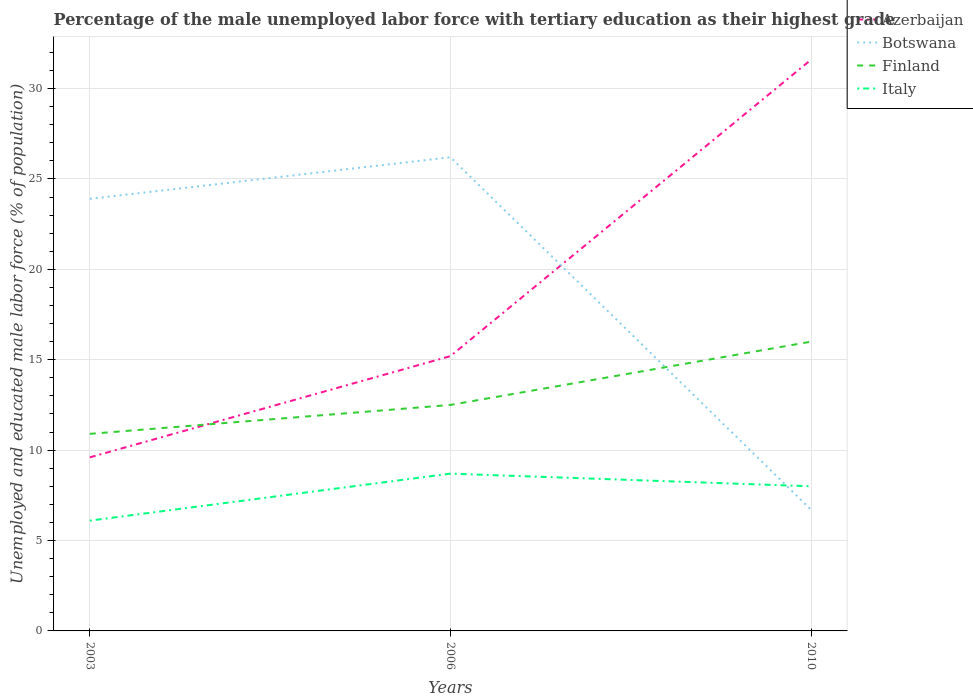How many different coloured lines are there?
Ensure brevity in your answer.  4. Does the line corresponding to Finland intersect with the line corresponding to Botswana?
Keep it short and to the point. Yes. Is the number of lines equal to the number of legend labels?
Make the answer very short. Yes. Across all years, what is the maximum percentage of the unemployed male labor force with tertiary education in Finland?
Make the answer very short. 10.9. In which year was the percentage of the unemployed male labor force with tertiary education in Finland maximum?
Ensure brevity in your answer.  2003. What is the total percentage of the unemployed male labor force with tertiary education in Finland in the graph?
Offer a terse response. -5.1. What is the difference between the highest and the second highest percentage of the unemployed male labor force with tertiary education in Azerbaijan?
Provide a succinct answer. 22. Is the percentage of the unemployed male labor force with tertiary education in Botswana strictly greater than the percentage of the unemployed male labor force with tertiary education in Finland over the years?
Your answer should be compact. No. How many lines are there?
Your answer should be very brief. 4. What is the difference between two consecutive major ticks on the Y-axis?
Make the answer very short. 5. Does the graph contain grids?
Your answer should be compact. Yes. Where does the legend appear in the graph?
Provide a succinct answer. Top right. What is the title of the graph?
Make the answer very short. Percentage of the male unemployed labor force with tertiary education as their highest grade. What is the label or title of the X-axis?
Your response must be concise. Years. What is the label or title of the Y-axis?
Your answer should be compact. Unemployed and educated male labor force (% of population). What is the Unemployed and educated male labor force (% of population) of Azerbaijan in 2003?
Your response must be concise. 9.6. What is the Unemployed and educated male labor force (% of population) of Botswana in 2003?
Your answer should be very brief. 23.9. What is the Unemployed and educated male labor force (% of population) in Finland in 2003?
Keep it short and to the point. 10.9. What is the Unemployed and educated male labor force (% of population) of Italy in 2003?
Ensure brevity in your answer.  6.1. What is the Unemployed and educated male labor force (% of population) of Azerbaijan in 2006?
Offer a terse response. 15.2. What is the Unemployed and educated male labor force (% of population) of Botswana in 2006?
Keep it short and to the point. 26.2. What is the Unemployed and educated male labor force (% of population) of Italy in 2006?
Your answer should be compact. 8.7. What is the Unemployed and educated male labor force (% of population) in Azerbaijan in 2010?
Give a very brief answer. 31.6. What is the Unemployed and educated male labor force (% of population) of Botswana in 2010?
Keep it short and to the point. 6.7. What is the Unemployed and educated male labor force (% of population) of Finland in 2010?
Provide a succinct answer. 16. What is the Unemployed and educated male labor force (% of population) of Italy in 2010?
Keep it short and to the point. 8. Across all years, what is the maximum Unemployed and educated male labor force (% of population) in Azerbaijan?
Your answer should be very brief. 31.6. Across all years, what is the maximum Unemployed and educated male labor force (% of population) of Botswana?
Keep it short and to the point. 26.2. Across all years, what is the maximum Unemployed and educated male labor force (% of population) in Finland?
Offer a very short reply. 16. Across all years, what is the maximum Unemployed and educated male labor force (% of population) in Italy?
Ensure brevity in your answer.  8.7. Across all years, what is the minimum Unemployed and educated male labor force (% of population) of Azerbaijan?
Your answer should be very brief. 9.6. Across all years, what is the minimum Unemployed and educated male labor force (% of population) in Botswana?
Offer a very short reply. 6.7. Across all years, what is the minimum Unemployed and educated male labor force (% of population) of Finland?
Offer a very short reply. 10.9. Across all years, what is the minimum Unemployed and educated male labor force (% of population) of Italy?
Ensure brevity in your answer.  6.1. What is the total Unemployed and educated male labor force (% of population) in Azerbaijan in the graph?
Offer a very short reply. 56.4. What is the total Unemployed and educated male labor force (% of population) of Botswana in the graph?
Give a very brief answer. 56.8. What is the total Unemployed and educated male labor force (% of population) of Finland in the graph?
Offer a terse response. 39.4. What is the total Unemployed and educated male labor force (% of population) in Italy in the graph?
Ensure brevity in your answer.  22.8. What is the difference between the Unemployed and educated male labor force (% of population) of Botswana in 2003 and that in 2006?
Provide a short and direct response. -2.3. What is the difference between the Unemployed and educated male labor force (% of population) in Finland in 2003 and that in 2006?
Make the answer very short. -1.6. What is the difference between the Unemployed and educated male labor force (% of population) in Azerbaijan in 2003 and that in 2010?
Your response must be concise. -22. What is the difference between the Unemployed and educated male labor force (% of population) of Botswana in 2003 and that in 2010?
Offer a very short reply. 17.2. What is the difference between the Unemployed and educated male labor force (% of population) of Finland in 2003 and that in 2010?
Your answer should be compact. -5.1. What is the difference between the Unemployed and educated male labor force (% of population) in Azerbaijan in 2006 and that in 2010?
Offer a terse response. -16.4. What is the difference between the Unemployed and educated male labor force (% of population) in Botswana in 2006 and that in 2010?
Your answer should be very brief. 19.5. What is the difference between the Unemployed and educated male labor force (% of population) in Azerbaijan in 2003 and the Unemployed and educated male labor force (% of population) in Botswana in 2006?
Offer a terse response. -16.6. What is the difference between the Unemployed and educated male labor force (% of population) of Azerbaijan in 2003 and the Unemployed and educated male labor force (% of population) of Finland in 2006?
Offer a terse response. -2.9. What is the difference between the Unemployed and educated male labor force (% of population) of Azerbaijan in 2003 and the Unemployed and educated male labor force (% of population) of Italy in 2006?
Offer a terse response. 0.9. What is the difference between the Unemployed and educated male labor force (% of population) in Botswana in 2003 and the Unemployed and educated male labor force (% of population) in Finland in 2006?
Make the answer very short. 11.4. What is the difference between the Unemployed and educated male labor force (% of population) in Botswana in 2003 and the Unemployed and educated male labor force (% of population) in Italy in 2006?
Offer a very short reply. 15.2. What is the difference between the Unemployed and educated male labor force (% of population) in Finland in 2003 and the Unemployed and educated male labor force (% of population) in Italy in 2006?
Offer a very short reply. 2.2. What is the difference between the Unemployed and educated male labor force (% of population) in Azerbaijan in 2003 and the Unemployed and educated male labor force (% of population) in Botswana in 2010?
Ensure brevity in your answer.  2.9. What is the difference between the Unemployed and educated male labor force (% of population) in Botswana in 2003 and the Unemployed and educated male labor force (% of population) in Finland in 2010?
Offer a terse response. 7.9. What is the difference between the Unemployed and educated male labor force (% of population) in Botswana in 2003 and the Unemployed and educated male labor force (% of population) in Italy in 2010?
Make the answer very short. 15.9. What is the difference between the Unemployed and educated male labor force (% of population) in Finland in 2003 and the Unemployed and educated male labor force (% of population) in Italy in 2010?
Ensure brevity in your answer.  2.9. What is the difference between the Unemployed and educated male labor force (% of population) of Azerbaijan in 2006 and the Unemployed and educated male labor force (% of population) of Botswana in 2010?
Your answer should be compact. 8.5. What is the difference between the Unemployed and educated male labor force (% of population) in Botswana in 2006 and the Unemployed and educated male labor force (% of population) in Finland in 2010?
Offer a very short reply. 10.2. What is the difference between the Unemployed and educated male labor force (% of population) in Botswana in 2006 and the Unemployed and educated male labor force (% of population) in Italy in 2010?
Your answer should be compact. 18.2. What is the difference between the Unemployed and educated male labor force (% of population) of Finland in 2006 and the Unemployed and educated male labor force (% of population) of Italy in 2010?
Your answer should be compact. 4.5. What is the average Unemployed and educated male labor force (% of population) in Botswana per year?
Keep it short and to the point. 18.93. What is the average Unemployed and educated male labor force (% of population) of Finland per year?
Ensure brevity in your answer.  13.13. What is the average Unemployed and educated male labor force (% of population) in Italy per year?
Keep it short and to the point. 7.6. In the year 2003, what is the difference between the Unemployed and educated male labor force (% of population) of Azerbaijan and Unemployed and educated male labor force (% of population) of Botswana?
Provide a short and direct response. -14.3. In the year 2003, what is the difference between the Unemployed and educated male labor force (% of population) in Azerbaijan and Unemployed and educated male labor force (% of population) in Finland?
Provide a succinct answer. -1.3. In the year 2003, what is the difference between the Unemployed and educated male labor force (% of population) in Botswana and Unemployed and educated male labor force (% of population) in Italy?
Keep it short and to the point. 17.8. In the year 2006, what is the difference between the Unemployed and educated male labor force (% of population) in Azerbaijan and Unemployed and educated male labor force (% of population) in Botswana?
Ensure brevity in your answer.  -11. In the year 2006, what is the difference between the Unemployed and educated male labor force (% of population) in Azerbaijan and Unemployed and educated male labor force (% of population) in Italy?
Offer a terse response. 6.5. In the year 2006, what is the difference between the Unemployed and educated male labor force (% of population) in Botswana and Unemployed and educated male labor force (% of population) in Finland?
Give a very brief answer. 13.7. In the year 2006, what is the difference between the Unemployed and educated male labor force (% of population) of Botswana and Unemployed and educated male labor force (% of population) of Italy?
Offer a very short reply. 17.5. In the year 2010, what is the difference between the Unemployed and educated male labor force (% of population) in Azerbaijan and Unemployed and educated male labor force (% of population) in Botswana?
Keep it short and to the point. 24.9. In the year 2010, what is the difference between the Unemployed and educated male labor force (% of population) of Azerbaijan and Unemployed and educated male labor force (% of population) of Finland?
Your response must be concise. 15.6. In the year 2010, what is the difference between the Unemployed and educated male labor force (% of population) of Azerbaijan and Unemployed and educated male labor force (% of population) of Italy?
Give a very brief answer. 23.6. In the year 2010, what is the difference between the Unemployed and educated male labor force (% of population) in Botswana and Unemployed and educated male labor force (% of population) in Finland?
Your answer should be very brief. -9.3. In the year 2010, what is the difference between the Unemployed and educated male labor force (% of population) of Botswana and Unemployed and educated male labor force (% of population) of Italy?
Keep it short and to the point. -1.3. In the year 2010, what is the difference between the Unemployed and educated male labor force (% of population) in Finland and Unemployed and educated male labor force (% of population) in Italy?
Keep it short and to the point. 8. What is the ratio of the Unemployed and educated male labor force (% of population) of Azerbaijan in 2003 to that in 2006?
Your response must be concise. 0.63. What is the ratio of the Unemployed and educated male labor force (% of population) of Botswana in 2003 to that in 2006?
Ensure brevity in your answer.  0.91. What is the ratio of the Unemployed and educated male labor force (% of population) in Finland in 2003 to that in 2006?
Make the answer very short. 0.87. What is the ratio of the Unemployed and educated male labor force (% of population) of Italy in 2003 to that in 2006?
Offer a very short reply. 0.7. What is the ratio of the Unemployed and educated male labor force (% of population) of Azerbaijan in 2003 to that in 2010?
Your answer should be compact. 0.3. What is the ratio of the Unemployed and educated male labor force (% of population) in Botswana in 2003 to that in 2010?
Offer a terse response. 3.57. What is the ratio of the Unemployed and educated male labor force (% of population) of Finland in 2003 to that in 2010?
Ensure brevity in your answer.  0.68. What is the ratio of the Unemployed and educated male labor force (% of population) of Italy in 2003 to that in 2010?
Provide a succinct answer. 0.76. What is the ratio of the Unemployed and educated male labor force (% of population) of Azerbaijan in 2006 to that in 2010?
Your answer should be compact. 0.48. What is the ratio of the Unemployed and educated male labor force (% of population) of Botswana in 2006 to that in 2010?
Your answer should be very brief. 3.91. What is the ratio of the Unemployed and educated male labor force (% of population) in Finland in 2006 to that in 2010?
Make the answer very short. 0.78. What is the ratio of the Unemployed and educated male labor force (% of population) in Italy in 2006 to that in 2010?
Ensure brevity in your answer.  1.09. What is the difference between the highest and the second highest Unemployed and educated male labor force (% of population) of Finland?
Your response must be concise. 3.5. What is the difference between the highest and the second highest Unemployed and educated male labor force (% of population) of Italy?
Offer a very short reply. 0.7. 